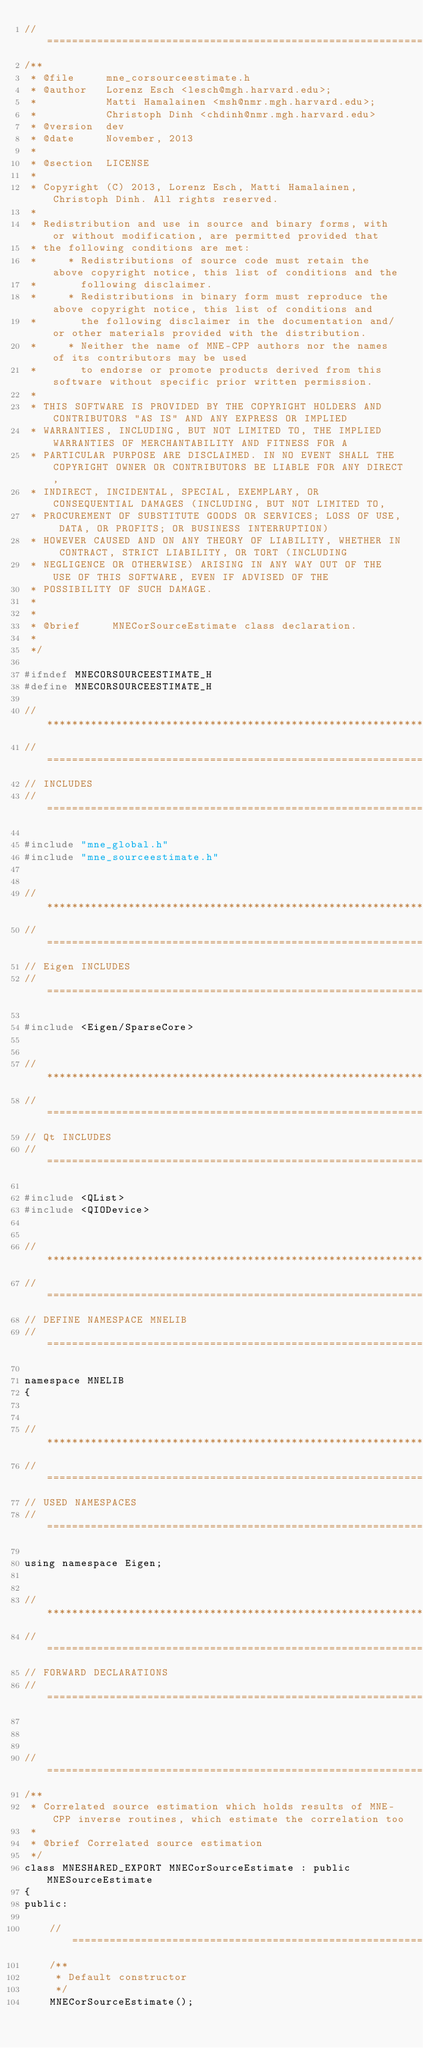<code> <loc_0><loc_0><loc_500><loc_500><_C_>//=============================================================================================================
/**
 * @file     mne_corsourceestimate.h
 * @author   Lorenz Esch <lesch@mgh.harvard.edu>;
 *           Matti Hamalainen <msh@nmr.mgh.harvard.edu>;
 *           Christoph Dinh <chdinh@nmr.mgh.harvard.edu>
 * @version  dev
 * @date     November, 2013
 *
 * @section  LICENSE
 *
 * Copyright (C) 2013, Lorenz Esch, Matti Hamalainen, Christoph Dinh. All rights reserved.
 *
 * Redistribution and use in source and binary forms, with or without modification, are permitted provided that
 * the following conditions are met:
 *     * Redistributions of source code must retain the above copyright notice, this list of conditions and the
 *       following disclaimer.
 *     * Redistributions in binary form must reproduce the above copyright notice, this list of conditions and
 *       the following disclaimer in the documentation and/or other materials provided with the distribution.
 *     * Neither the name of MNE-CPP authors nor the names of its contributors may be used
 *       to endorse or promote products derived from this software without specific prior written permission.
 *
 * THIS SOFTWARE IS PROVIDED BY THE COPYRIGHT HOLDERS AND CONTRIBUTORS "AS IS" AND ANY EXPRESS OR IMPLIED
 * WARRANTIES, INCLUDING, BUT NOT LIMITED TO, THE IMPLIED WARRANTIES OF MERCHANTABILITY AND FITNESS FOR A
 * PARTICULAR PURPOSE ARE DISCLAIMED. IN NO EVENT SHALL THE COPYRIGHT OWNER OR CONTRIBUTORS BE LIABLE FOR ANY DIRECT,
 * INDIRECT, INCIDENTAL, SPECIAL, EXEMPLARY, OR CONSEQUENTIAL DAMAGES (INCLUDING, BUT NOT LIMITED TO,
 * PROCUREMENT OF SUBSTITUTE GOODS OR SERVICES; LOSS OF USE, DATA, OR PROFITS; OR BUSINESS INTERRUPTION)
 * HOWEVER CAUSED AND ON ANY THEORY OF LIABILITY, WHETHER IN CONTRACT, STRICT LIABILITY, OR TORT (INCLUDING
 * NEGLIGENCE OR OTHERWISE) ARISING IN ANY WAY OUT OF THE USE OF THIS SOFTWARE, EVEN IF ADVISED OF THE
 * POSSIBILITY OF SUCH DAMAGE.
 *
 *
 * @brief     MNECorSourceEstimate class declaration.
 *
 */

#ifndef MNECORSOURCEESTIMATE_H
#define MNECORSOURCEESTIMATE_H

//*************************************************************************************************************
//=============================================================================================================
// INCLUDES
//=============================================================================================================

#include "mne_global.h"
#include "mne_sourceestimate.h"


//*************************************************************************************************************
//=============================================================================================================
// Eigen INCLUDES
//=============================================================================================================

#include <Eigen/SparseCore>


//*************************************************************************************************************
//=============================================================================================================
// Qt INCLUDES
//=============================================================================================================

#include <QList>
#include <QIODevice>


//*************************************************************************************************************
//=============================================================================================================
// DEFINE NAMESPACE MNELIB
//=============================================================================================================

namespace MNELIB
{


//*************************************************************************************************************
//=============================================================================================================
// USED NAMESPACES
//=============================================================================================================

using namespace Eigen;


//*************************************************************************************************************
//=============================================================================================================
// FORWARD DECLARATIONS
//=============================================================================================================



//=============================================================================================================
/**
 * Correlated source estimation which holds results of MNE-CPP inverse routines, which estimate the correlation too
 *
 * @brief Correlated source estimation
 */
class MNESHARED_EXPORT MNECorSourceEstimate : public MNESourceEstimate
{
public:

    //=========================================================================================================
    /**
     * Default constructor
     */
    MNECorSourceEstimate();
</code> 